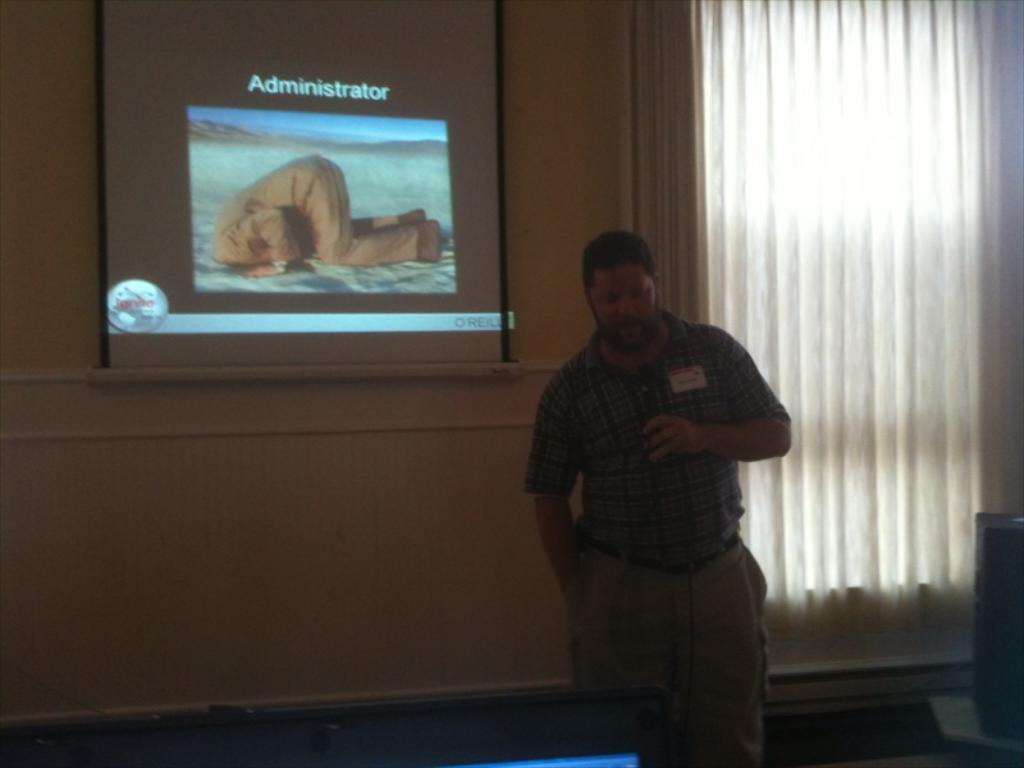What is the main subject of the image? The main subject of the image is a man standing. What is the man wearing? The man is wearing clothes. What object is the man holding in his hand? The man is holding a microphone in his hand. What can be seen behind the man? There is a projected screen behind the man. What window treatment is present in the image? There is a curtain associated with a window in the image. What type of canvas is visible in the image? There is no canvas present in the image. What type of plantation can be seen in the background of the image? There is no plantation visible in the image; it features a man standing with a microphone and a projected screen. 